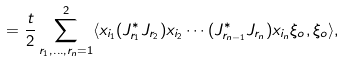Convert formula to latex. <formula><loc_0><loc_0><loc_500><loc_500>= \frac { t } { 2 } \sum _ { r _ { 1 } , \dots , r _ { n } = 1 } ^ { 2 } \langle x _ { i _ { 1 } } ( J _ { r _ { 1 } } ^ { * } J _ { r _ { 2 } } ) x _ { i _ { 2 } } \cdots ( J _ { r _ { n - 1 } } ^ { * } J _ { r _ { n } } ) x _ { i _ { n } } \xi _ { o } , \xi _ { o } \rangle ,</formula> 